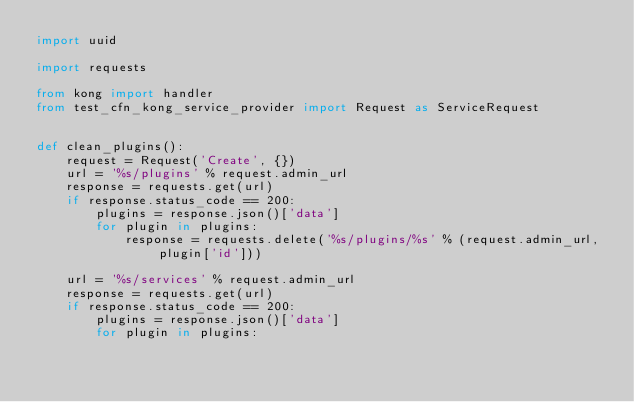<code> <loc_0><loc_0><loc_500><loc_500><_Python_>import uuid

import requests

from kong import handler
from test_cfn_kong_service_provider import Request as ServiceRequest


def clean_plugins():
    request = Request('Create', {})
    url = '%s/plugins' % request.admin_url
    response = requests.get(url)
    if response.status_code == 200:
        plugins = response.json()['data']
        for plugin in plugins:
            response = requests.delete('%s/plugins/%s' % (request.admin_url, plugin['id']))

    url = '%s/services' % request.admin_url
    response = requests.get(url)
    if response.status_code == 200:
        plugins = response.json()['data']
        for plugin in plugins:</code> 